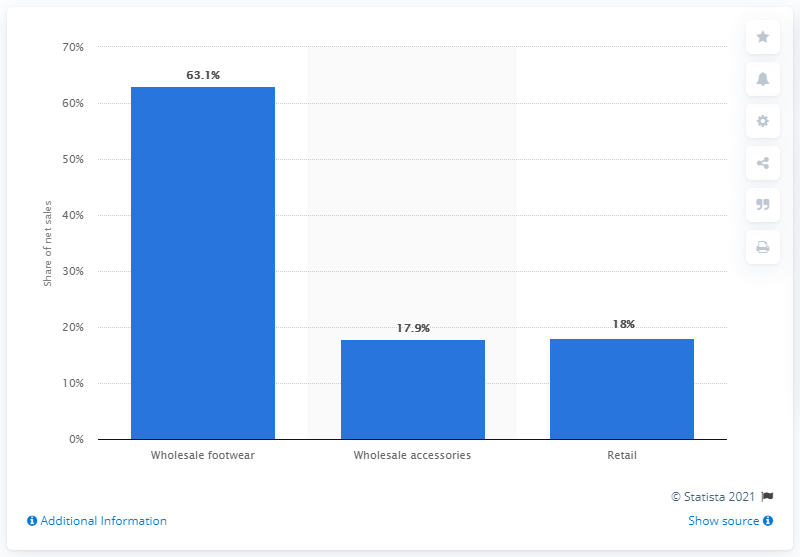Draw attention to some important aspects in this diagram. In 2019, wholesale footwear accounted for 63.1% of Steve Madden's total net sales. 